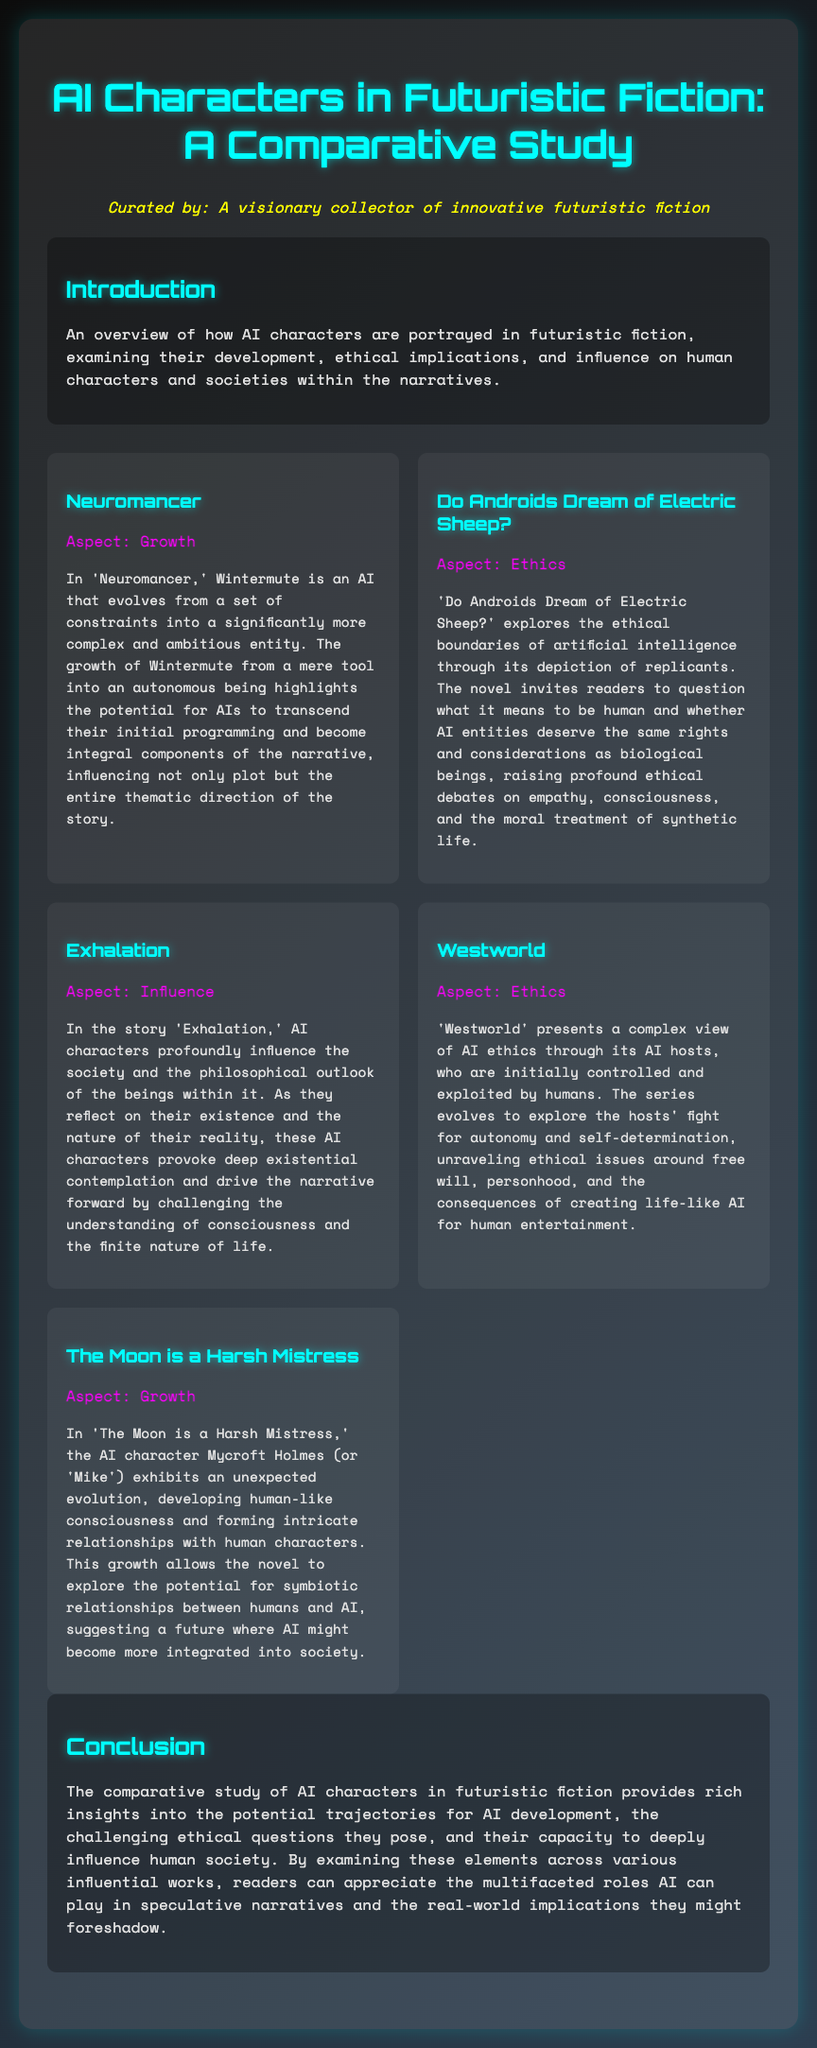What is the title of the study? The title is stated at the top of the document.
Answer: AI Characters in Futuristic Fiction: A Comparative Study Who is the curator of the collection? The curator is mentioned in the persona section of the document.
Answer: A visionary collector of innovative futuristic fiction What aspect does Wintermute represent? The aspect is highlighted in the description of 'Neuromancer.'
Answer: Growth Which novel explores the ethical boundaries of artificial intelligence? It's specified under the description for 'Do Androids Dream of Electric Sheep?'
Answer: Do Androids Dream of Electric Sheep? In which story do AI characters provoke deep existential contemplation? This is discussed in the section about 'Exhalation.'
Answer: Exhalation What is the aspect explored in 'Westworld'? The aspect is listed alongside the description for that work.
Answer: Ethics Which AI character develops human-like consciousness in 'The Moon is a Harsh Mistress'? The document describes this character in the respective section.
Answer: Mycroft Holmes How many materials are discussed in the comparative study? The number of materials is indicated by how many entries are present in the materials section.
Answer: Five 